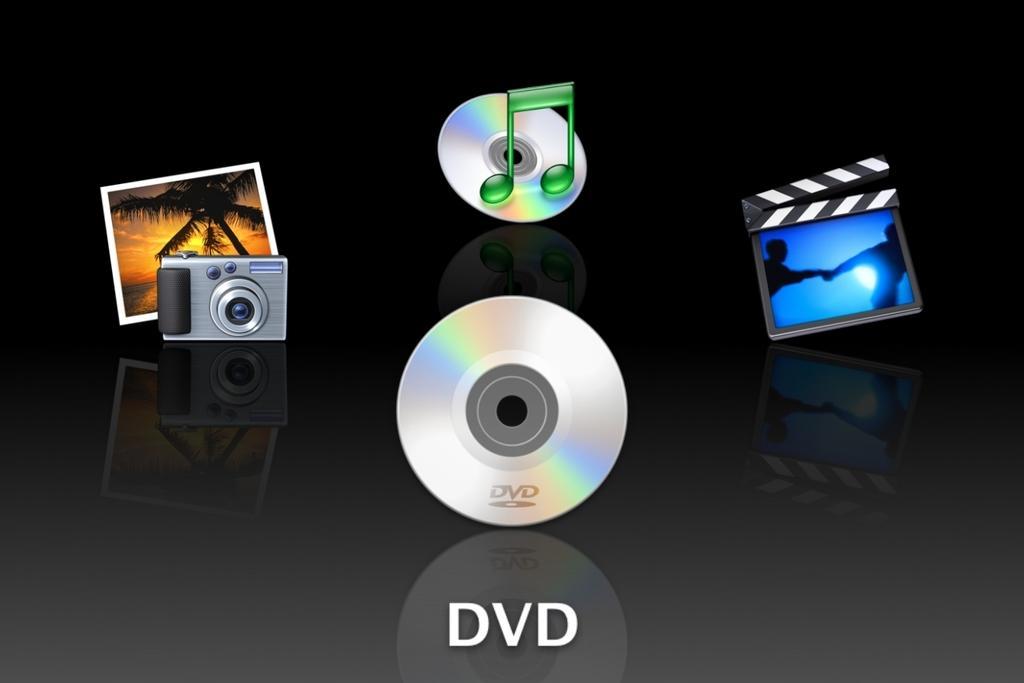In one or two sentences, can you explain what this image depicts? In this image we can see the depiction of the DVD's, camera, photo frame, music logo and the background of the image is in black color. 